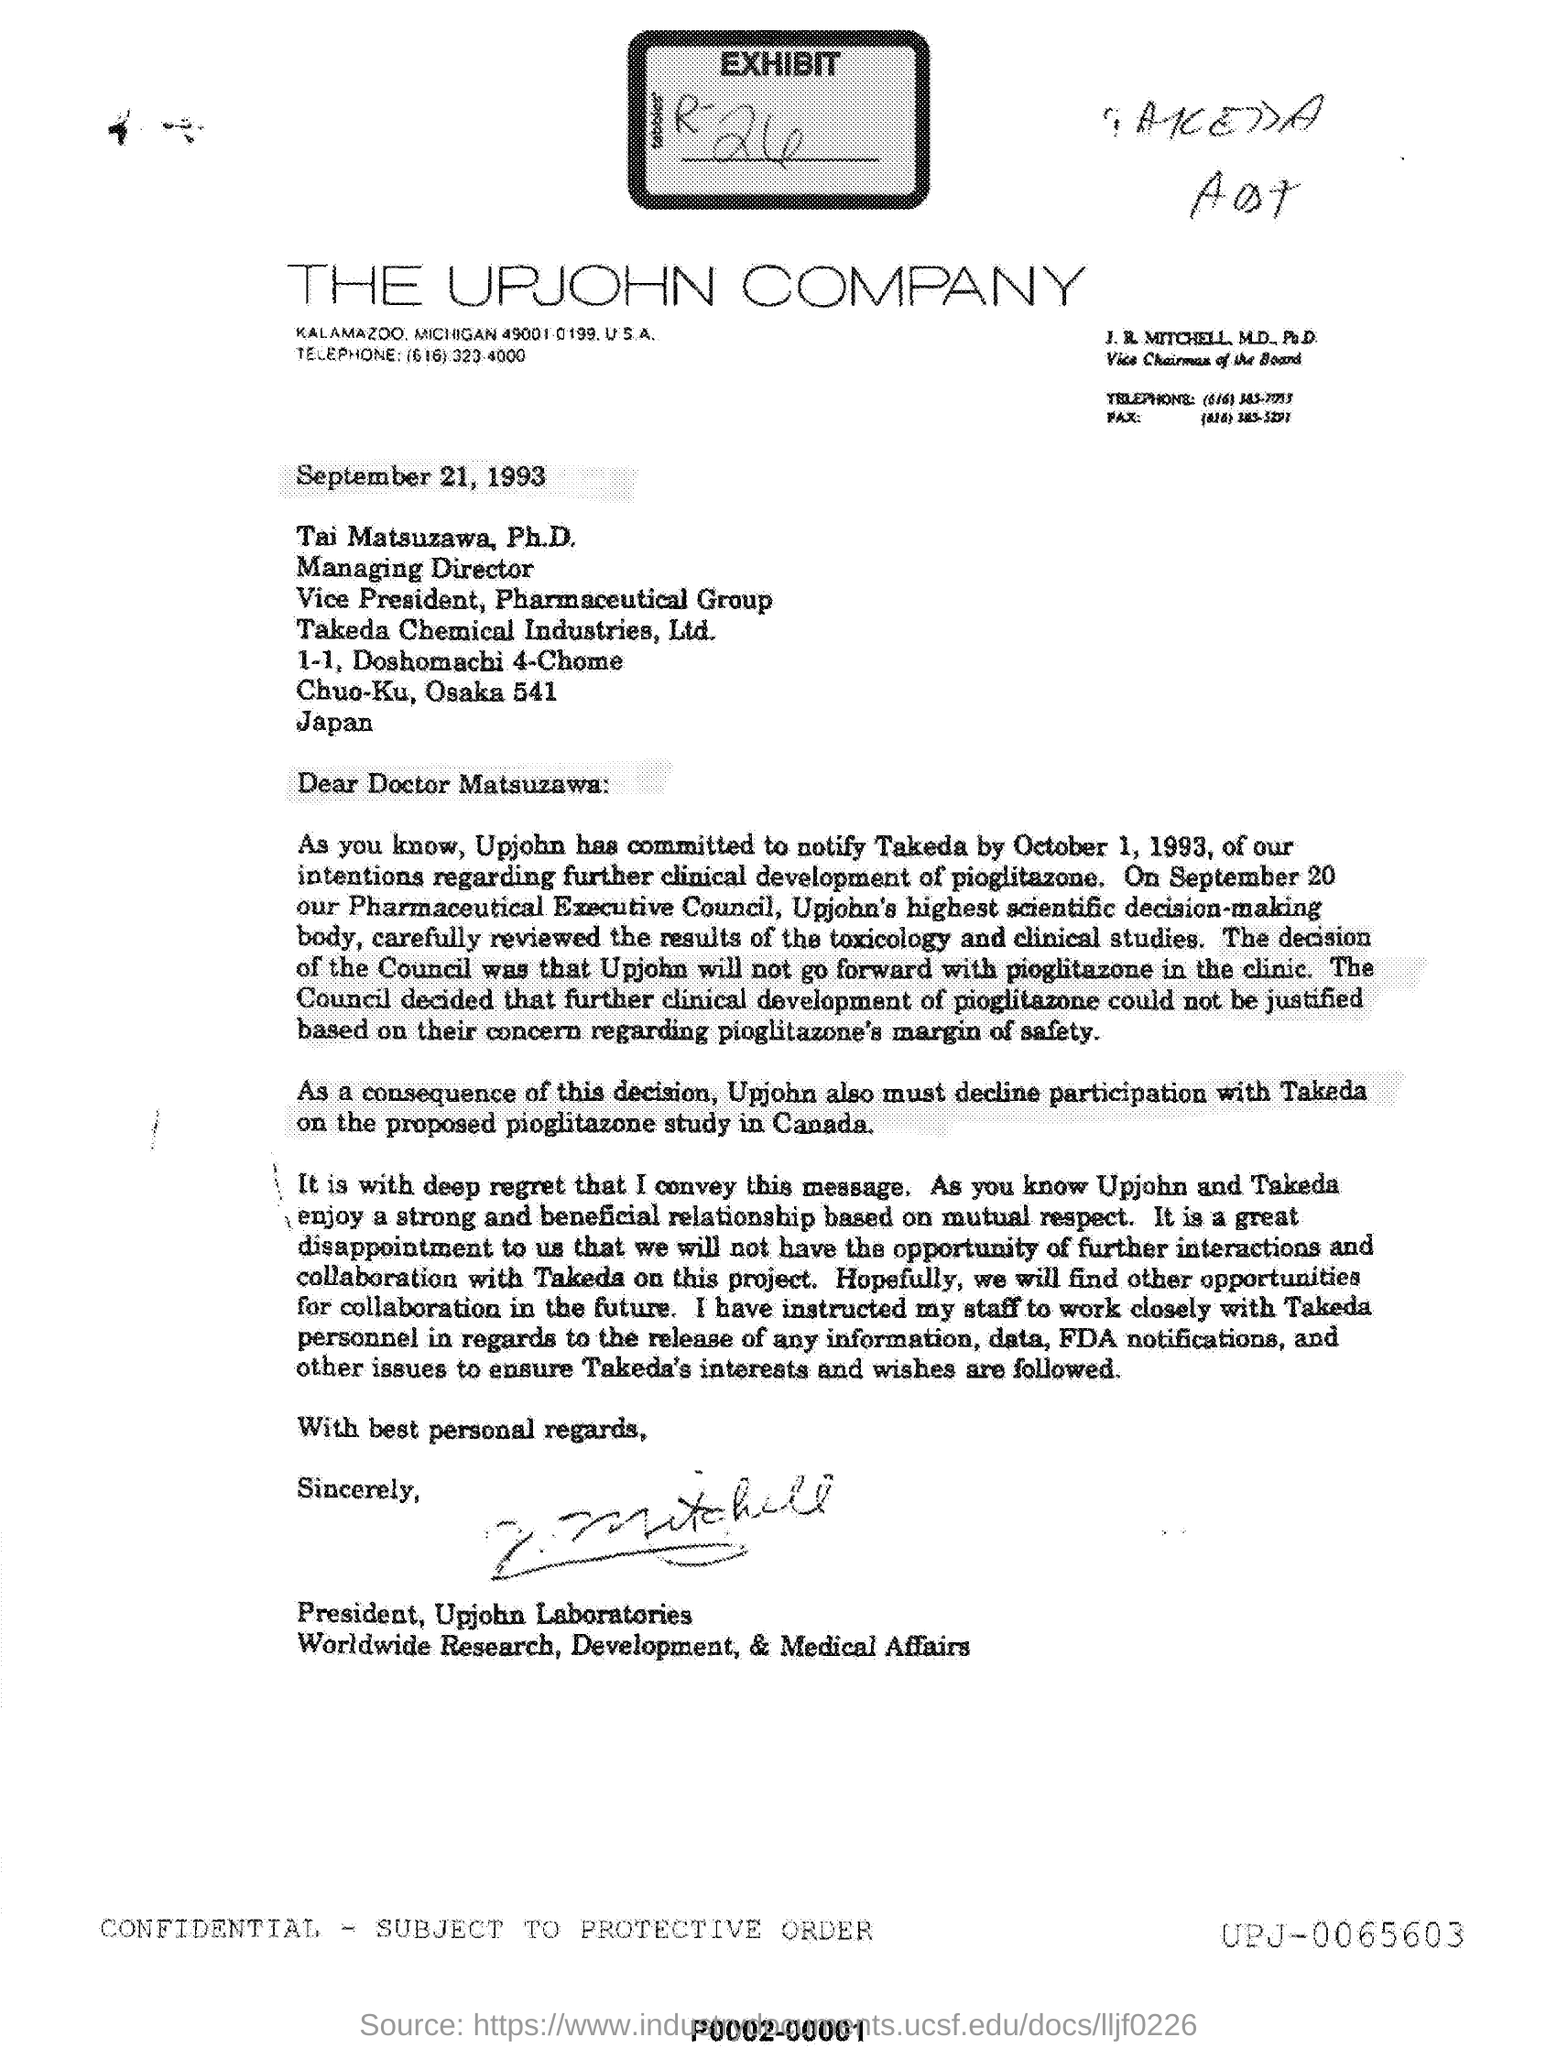Draw attention to some important aspects in this diagram. I hereby declare that the name of the company is THE UPJOHN COMPANY. The date mentioned is September 21, 1993. As a result of the decision made by Upjohn, the company is unable to participate with Takeda. This letter is addressed to Matsuzawa. 